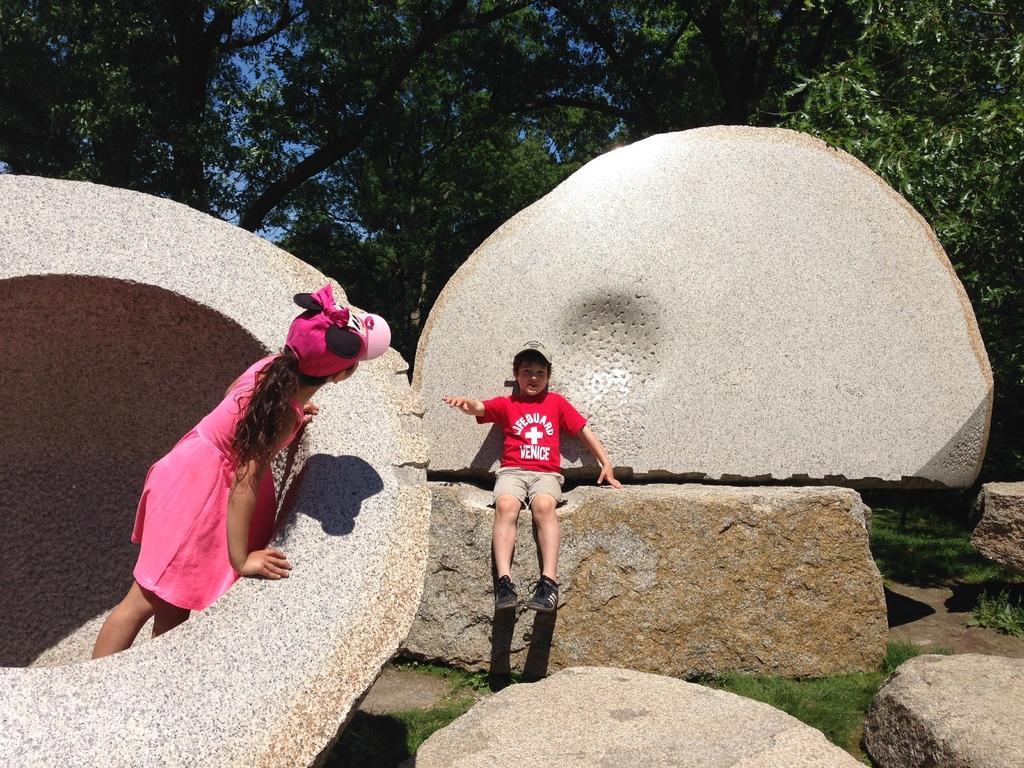Can you describe this image briefly? In this image there are two kids playing on rocks, in the background there are trees. 